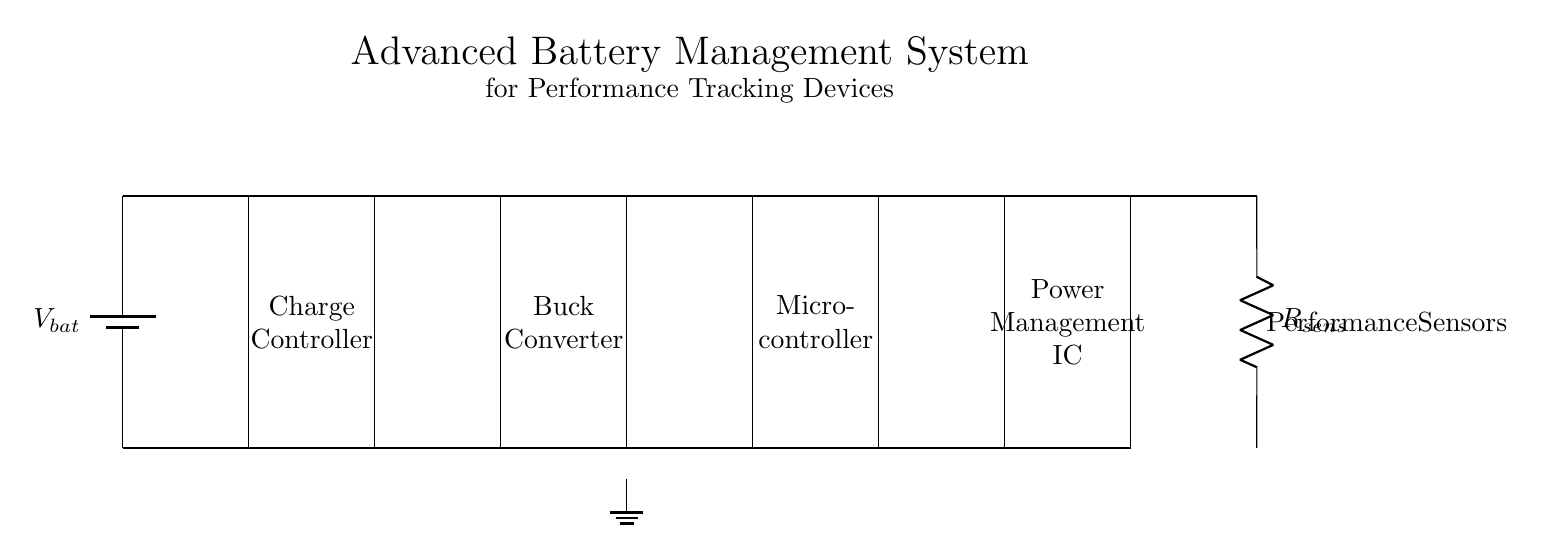What components are present in this circuit? The circuit contains a battery, charge controller, buck converter, microcontroller, power management IC, and performance sensors. Each component is represented and labeled in the diagram, facilitating identification.
Answer: battery, charge controller, buck converter, microcontroller, power management IC, performance sensors What is the function of the buck converter in this circuit? The buck converter is used to step down the voltage from the input of the charge controller to the voltage levels suitable for microcontroller operation. It allows efficient power management for sensitive electronics.
Answer: voltage step-down How does the current flow through the charge controller? Current flows from the battery through the charge controller, which regulates the charging process before passing it to the buck converter. The diagram shows a direct connection from the battery to the charge controller, indicating the direction of flow.
Answer: from battery to buck converter What type of sensors are used in this system? The diagram specifically labels these as performance sensors, indicating they are likely used to track metrics or data relevant to the elite players' performance, supporting data analysis.
Answer: performance sensors How many levels of power management are present in this circuit? There are two key levels of power management indicated: the charge controller and the power management IC, highlighting two distinct stages where power is regulated and optimized for device performance.
Answer: two levels What role does the microcontroller serve in this circuit? The microcontroller acts as the central processing unit that manages the data from performance sensors and coordinates the power distribution from the buck converter and power management IC for optimal device operation.
Answer: central processing unit 